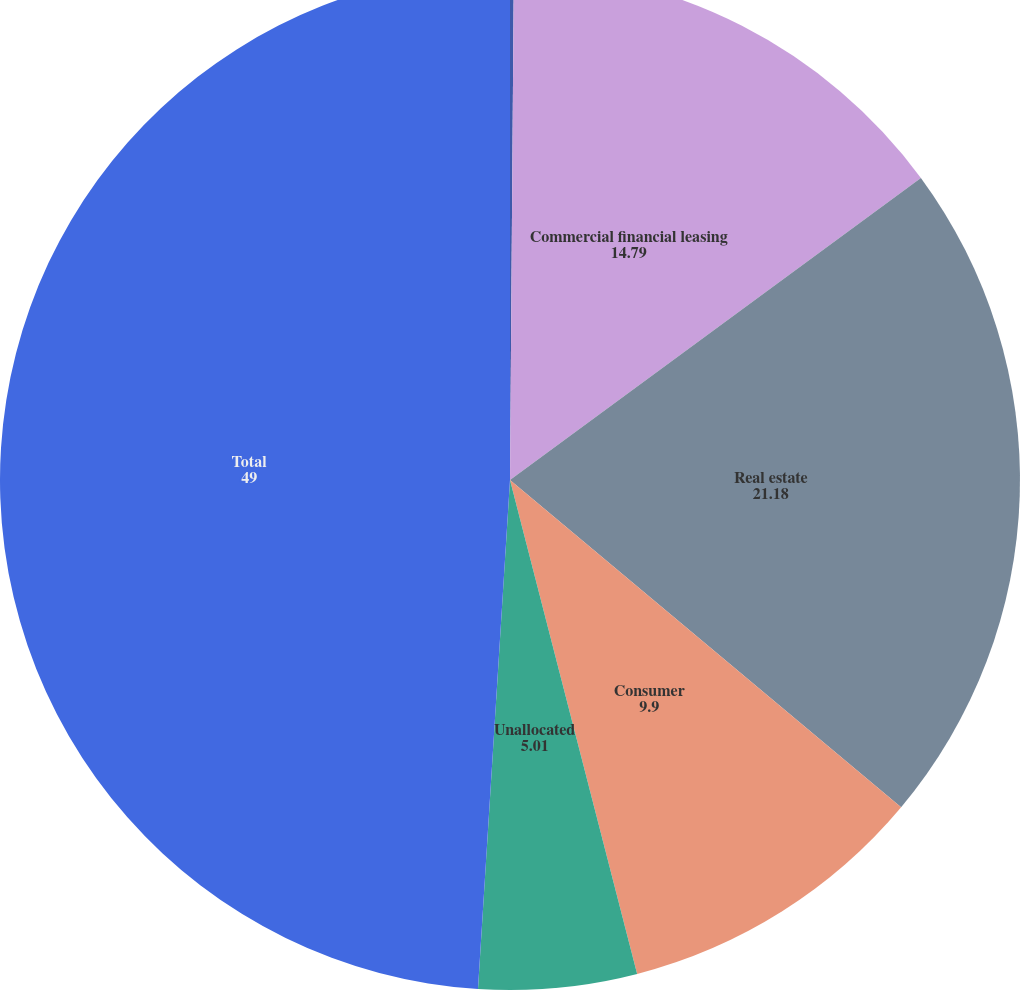<chart> <loc_0><loc_0><loc_500><loc_500><pie_chart><fcel>December 31<fcel>Commercial financial leasing<fcel>Real estate<fcel>Consumer<fcel>Unallocated<fcel>Total<nl><fcel>0.12%<fcel>14.79%<fcel>21.18%<fcel>9.9%<fcel>5.01%<fcel>49.0%<nl></chart> 